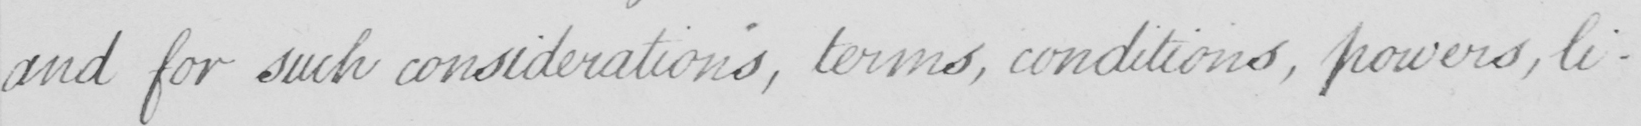Please provide the text content of this handwritten line. and for such considerations , terms , conditions , powers , li- 